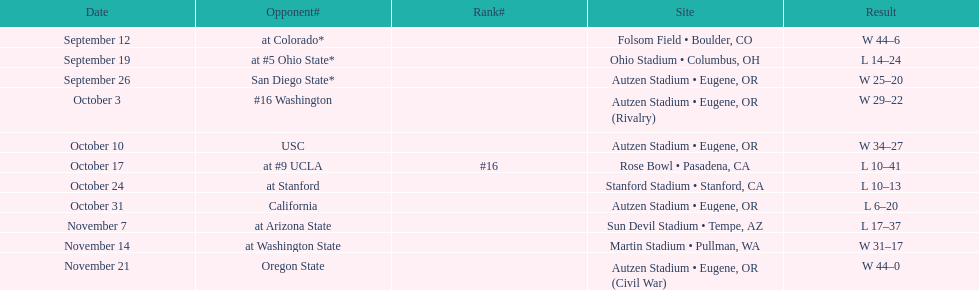Who was their last opponent of the season? Oregon State. 